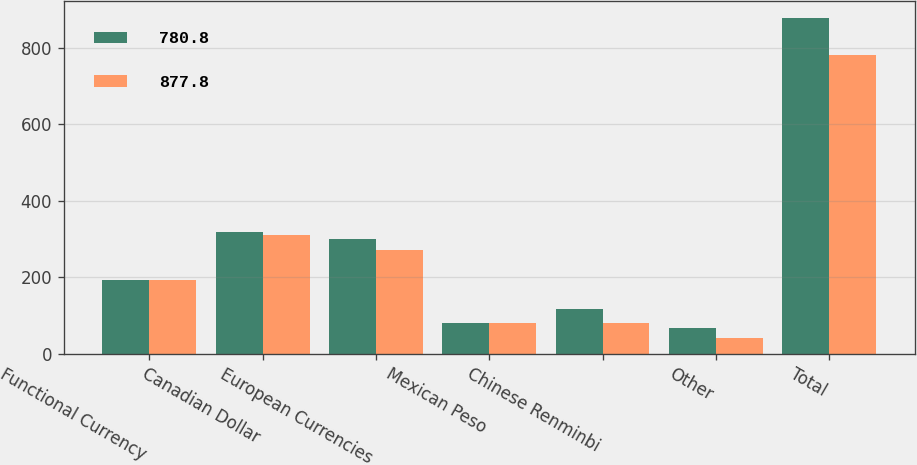<chart> <loc_0><loc_0><loc_500><loc_500><stacked_bar_chart><ecel><fcel>Functional Currency<fcel>Canadian Dollar<fcel>European Currencies<fcel>Mexican Peso<fcel>Chinese Renminbi<fcel>Other<fcel>Total<nl><fcel>780.8<fcel>192.85<fcel>316.9<fcel>299.5<fcel>79.8<fcel>115.7<fcel>65.9<fcel>877.8<nl><fcel>877.8<fcel>192.85<fcel>311.2<fcel>270<fcel>80<fcel>79.1<fcel>40.5<fcel>780.8<nl></chart> 